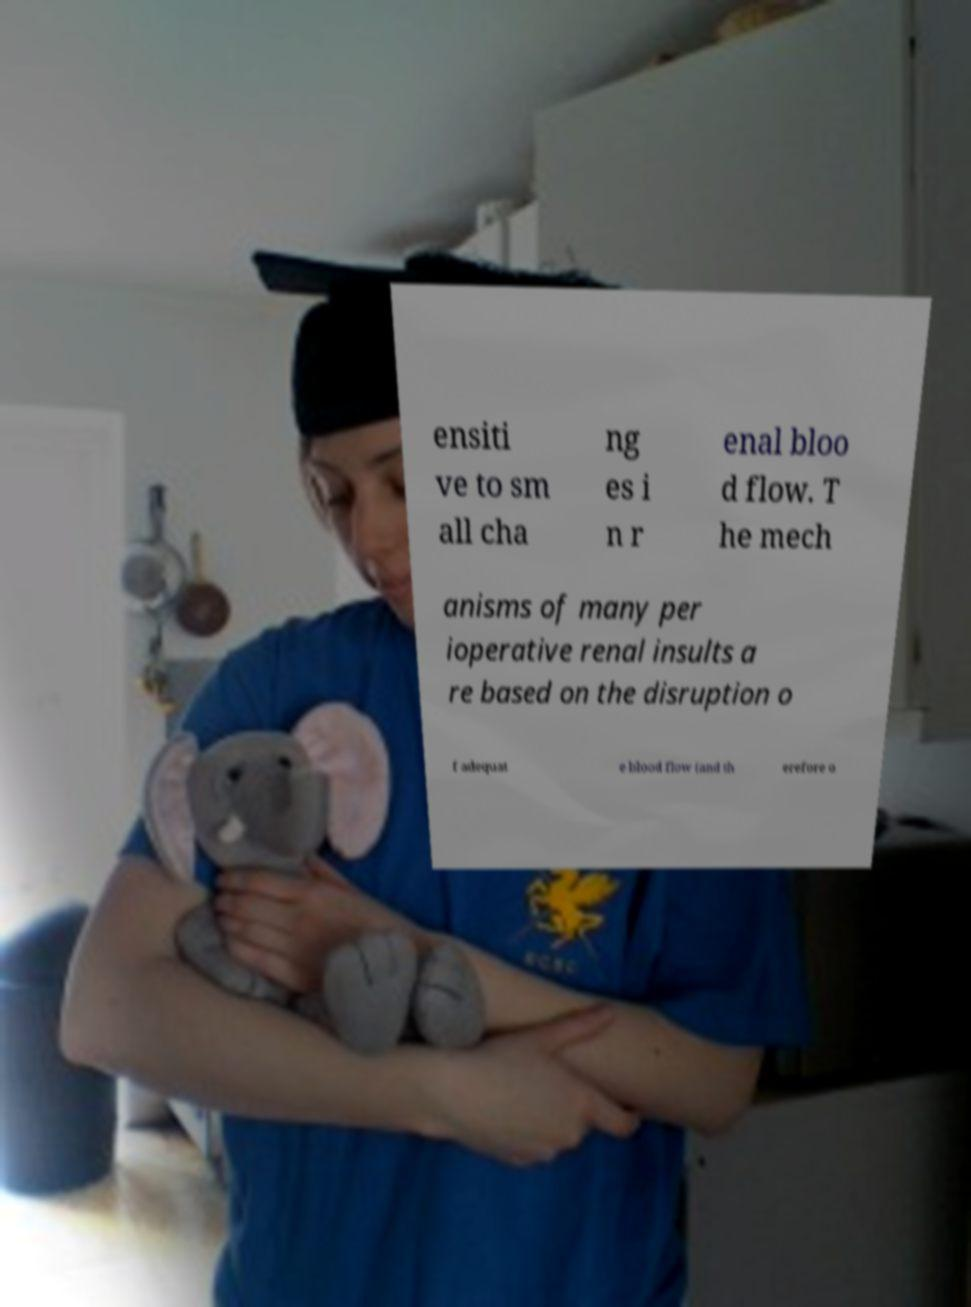Please read and relay the text visible in this image. What does it say? ensiti ve to sm all cha ng es i n r enal bloo d flow. T he mech anisms of many per ioperative renal insults a re based on the disruption o f adequat e blood flow (and th erefore o 